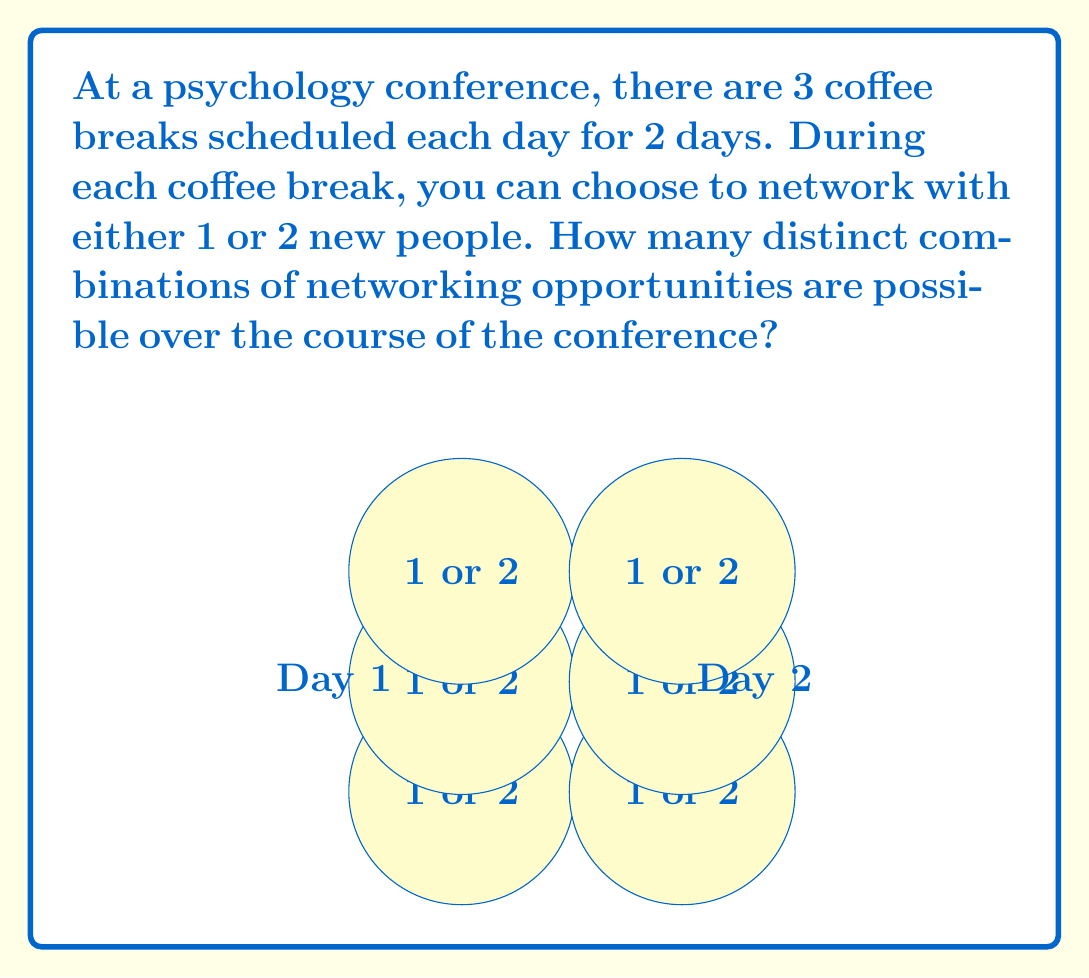Can you answer this question? Let's approach this step-by-step:

1) We have 6 coffee breaks in total (3 per day for 2 days).

2) For each coffee break, we have 2 choices: network with either 1 or 2 new people.

3) This scenario can be modeled as a sequence of 6 independent choices, where each choice has 2 options.

4) In combinatorics, when we have a sequence of independent choices, we multiply the number of options for each choice.

5) Therefore, we can calculate the total number of distinct combinations as:

   $$2 \times 2 \times 2 \times 2 \times 2 \times 2 = 2^6$$

6) We can simplify this:

   $$2^6 = 64$$

Thus, there are 64 distinct combinations of networking opportunities over the course of the conference.
Answer: $64$ 